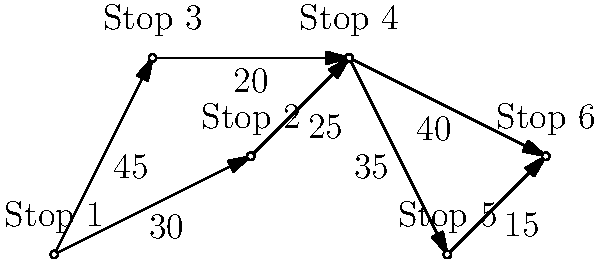As a rest stop manager, you're tasked with finding the shortest route between Stop 1 and Stop 6 on the highway network shown in the diagram. Each edge represents a road segment, and the number on each edge indicates the distance in miles. What is the length of the shortest path from Stop 1 to Stop 6? To find the shortest path from Stop 1 to Stop 6, we need to consider all possible routes and their total distances. Let's break it down step-by-step:

1. Identify possible paths:
   Path 1: 1 → 2 → 4 → 6
   Path 2: 1 → 2 → 4 → 5 → 6
   Path 3: 1 → 3 → 4 → 6
   Path 4: 1 → 3 → 4 → 5 → 6

2. Calculate the distance for each path:
   Path 1: 1 → 2 → 4 → 6 = 30 + 25 + 40 = 95 miles
   Path 2: 1 → 2 → 4 → 5 → 6 = 30 + 25 + 35 + 15 = 105 miles
   Path 3: 1 → 3 → 4 → 6 = 45 + 20 + 40 = 105 miles
   Path 4: 1 → 3 → 4 → 5 → 6 = 45 + 20 + 35 + 15 = 115 miles

3. Compare the total distances:
   Path 1: 95 miles
   Path 2: 105 miles
   Path 3: 105 miles
   Path 4: 115 miles

4. Identify the shortest path:
   The shortest path is Path 1, which goes through Stops 1 → 2 → 4 → 6.

5. Calculate the total distance of the shortest path:
   Shortest path distance = 30 + 25 + 40 = 95 miles

Therefore, the length of the shortest path from Stop 1 to Stop 6 is 95 miles.
Answer: 95 miles 